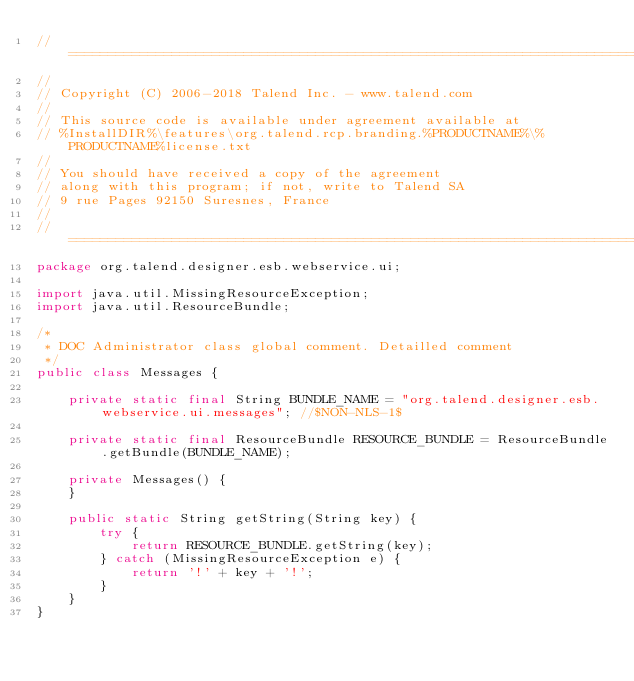Convert code to text. <code><loc_0><loc_0><loc_500><loc_500><_Java_>// ============================================================================
//
// Copyright (C) 2006-2018 Talend Inc. - www.talend.com
//
// This source code is available under agreement available at
// %InstallDIR%\features\org.talend.rcp.branding.%PRODUCTNAME%\%PRODUCTNAME%license.txt
//
// You should have received a copy of the agreement
// along with this program; if not, write to Talend SA
// 9 rue Pages 92150 Suresnes, France
//
// ============================================================================
package org.talend.designer.esb.webservice.ui;

import java.util.MissingResourceException;
import java.util.ResourceBundle;

/*
 * DOC Administrator class global comment. Detailled comment
 */
public class Messages {

    private static final String BUNDLE_NAME = "org.talend.designer.esb.webservice.ui.messages"; //$NON-NLS-1$

    private static final ResourceBundle RESOURCE_BUNDLE = ResourceBundle.getBundle(BUNDLE_NAME);

    private Messages() {
    }

    public static String getString(String key) {
        try {
            return RESOURCE_BUNDLE.getString(key);
        } catch (MissingResourceException e) {
            return '!' + key + '!';
        }
    }
}
</code> 